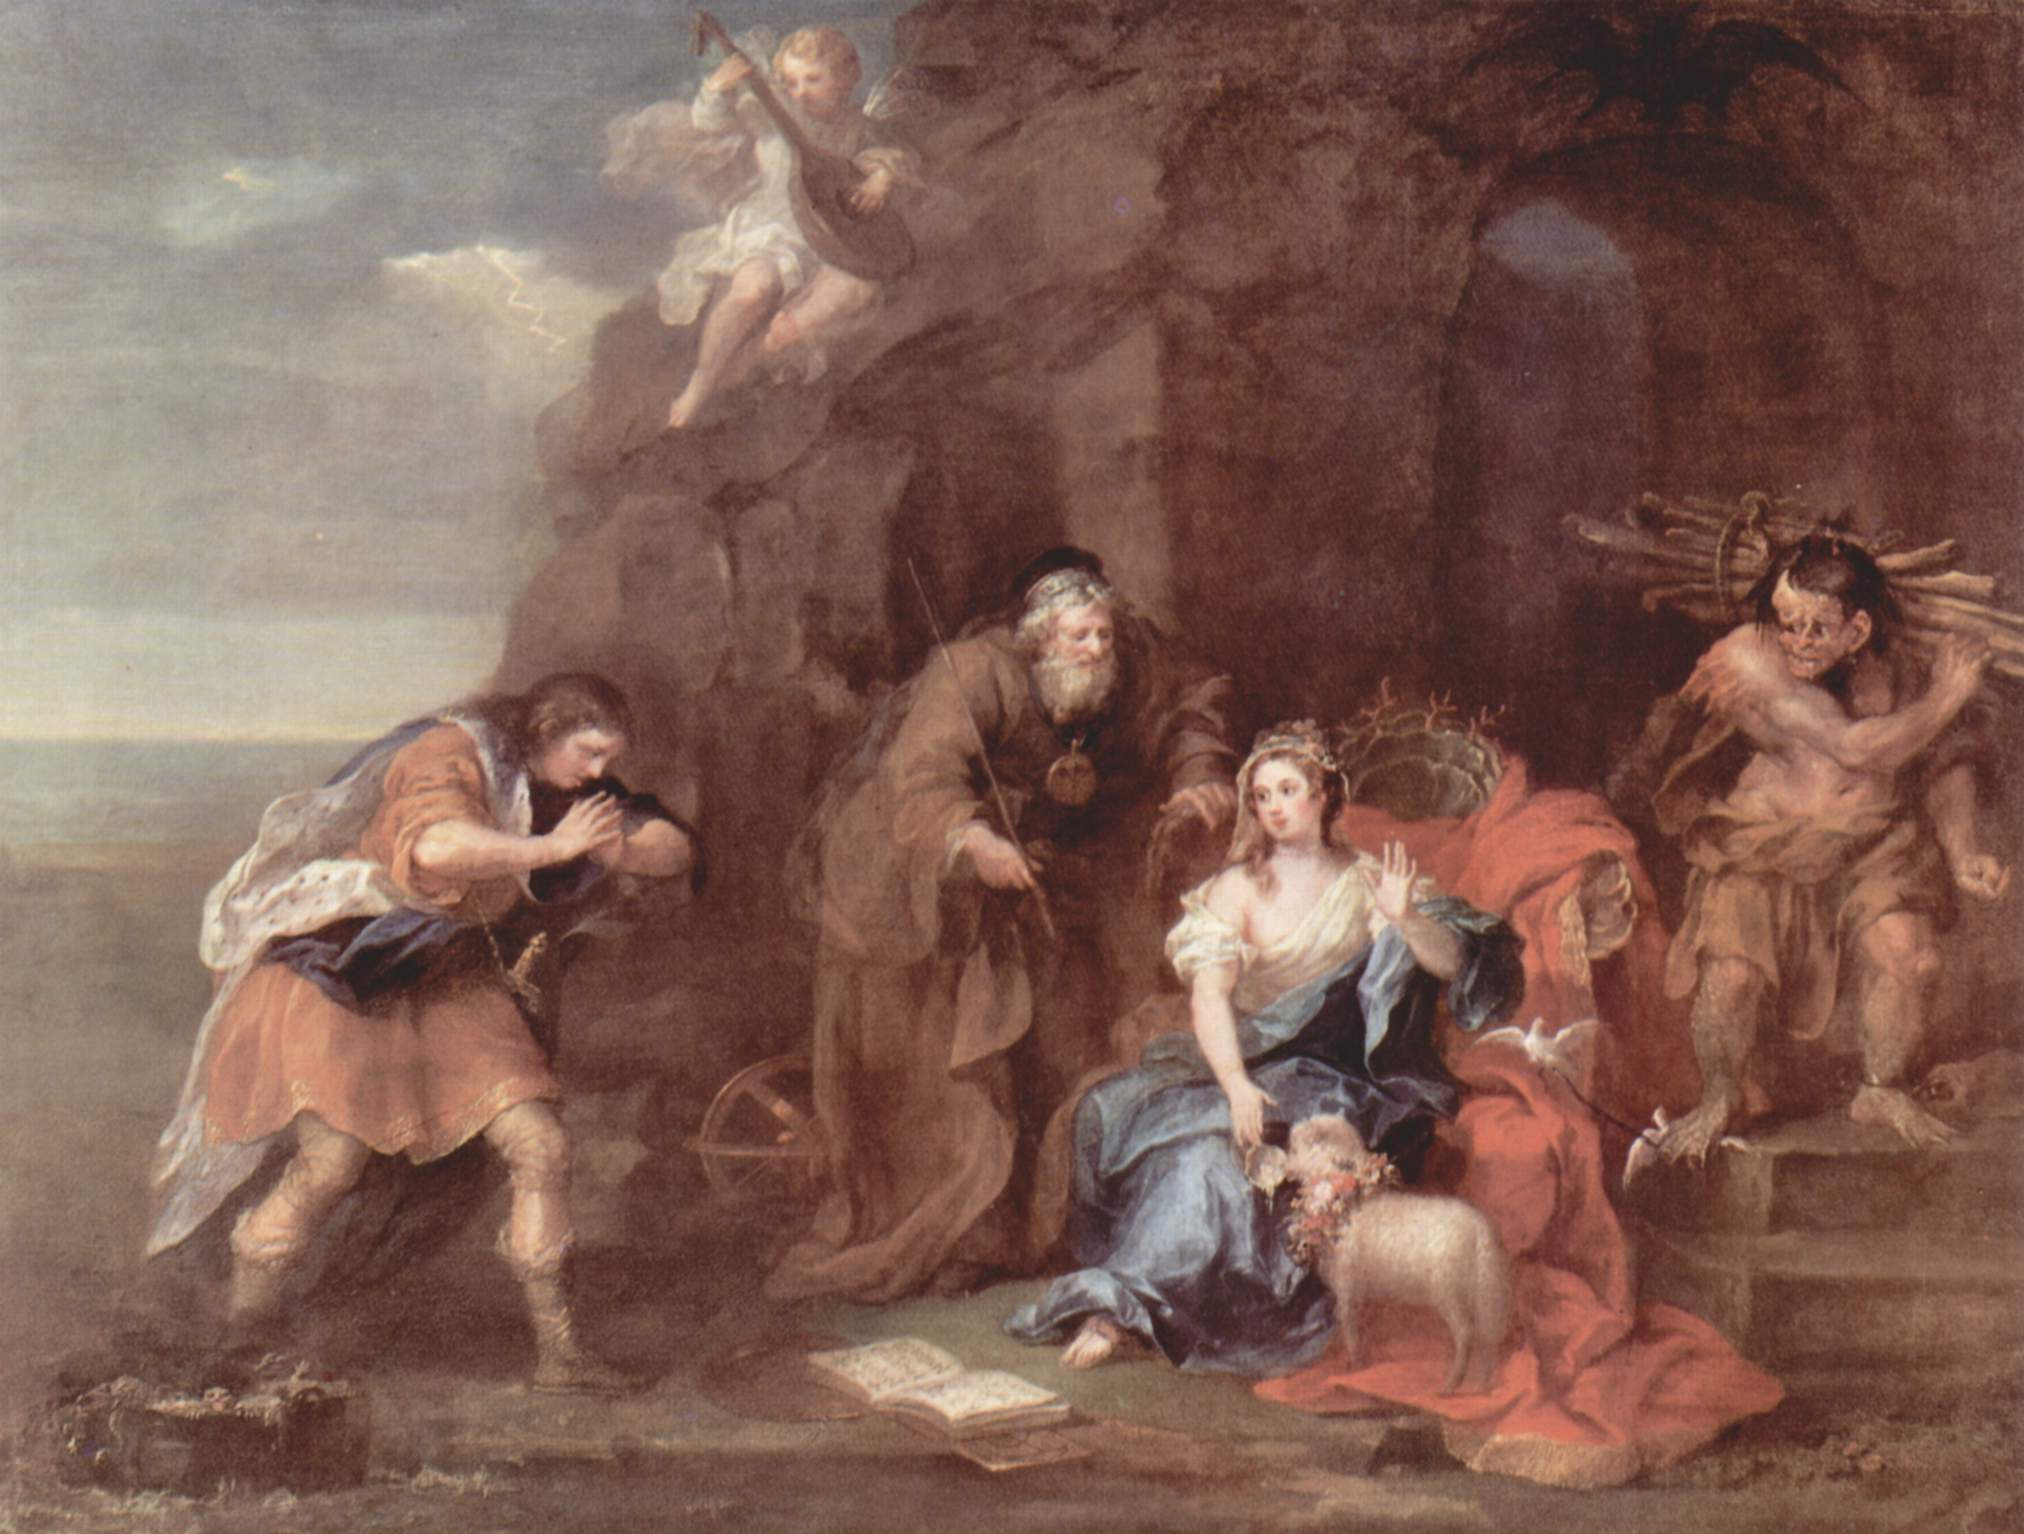Imagine the story behind this scene. Can you create a narrative that fits the elements in the painting? In an ancient land, nestled within the depths of a secluded cavern, a princess named Seraphina found respite from the burdens of her realm. Adorned in a regal blue dress, she reclined on a cushion of crimson velvet, seeking solace in the pages of an ancient tome that spoke of forgotten legends and mystical tales.

Her trusted advisor, wise and stoic, stood by her side, always ready with counsel and support. On a carved stone perch to her left, a minstrel played a melodious tune on his flute, his notes weaving a tapestry of sound that resonated through the cavern, soothing troubled hearts and uplifting spirits.

Above them, cherubic beings fluttered, their presence a symbol of divine favor and blessing. They held a garland of flowers, a token of celebration for an impending festivity that would bring hope and renewal to the land. In the background, a rugged warrior emerged from the shadowy depths, bearing the fruits of his labor, a testament to the hard-won peace and prosperity the kingdom now enjoyed.

This tranquil interlude, bathed in the dramatic light of the Baroque style, encapsulated the harmony and balance Seraphina's reign had brought. Yet, it was also a moment of reflection, reminding her and her subjects of the journey they had undertaken and the divine grace that had guided their steps. What if this painting depicted a futuristic scene instead? If we reimagine this painting as a futuristic scene, it transforms into a tableau of advanced civilization where technology and tradition coexist. The central figure, no longer a princess, is a revered scientist clad in a sleek, bioluminescent suit. She sits on a levitating cushion, engrossed in a holographic book that projects ancient texts and futuristic schematics simultaneously.

Her advisor is now an AI companion in the form of a humanoid robot, offering data analysis and strategic advice. To her left, the musician is a digital artist, manipulating sound waves through an advanced interface, creating music that merges classical harmony with synthetic innovation. The cherubs are now ethereal avatars, digital manifestations of AI, celebrating human achievement and collaboration.

In this futuristic setting, the rocky cavern is replaced by an underground research facility, surrounded by walls of transparent screens displaying real-time data and historical archives. The rugged warrior is a resilient explorer, returning from a mission to the outer colonies, bearing sharegpt4v/samples and artifacts that tell the story of humanity's expansion and survival.

This reimagined scene speaks to the perpetual quest for knowledge, the seamless integration of technology and culture, and the unyielding spirit of exploration and discovery that defines the future. 